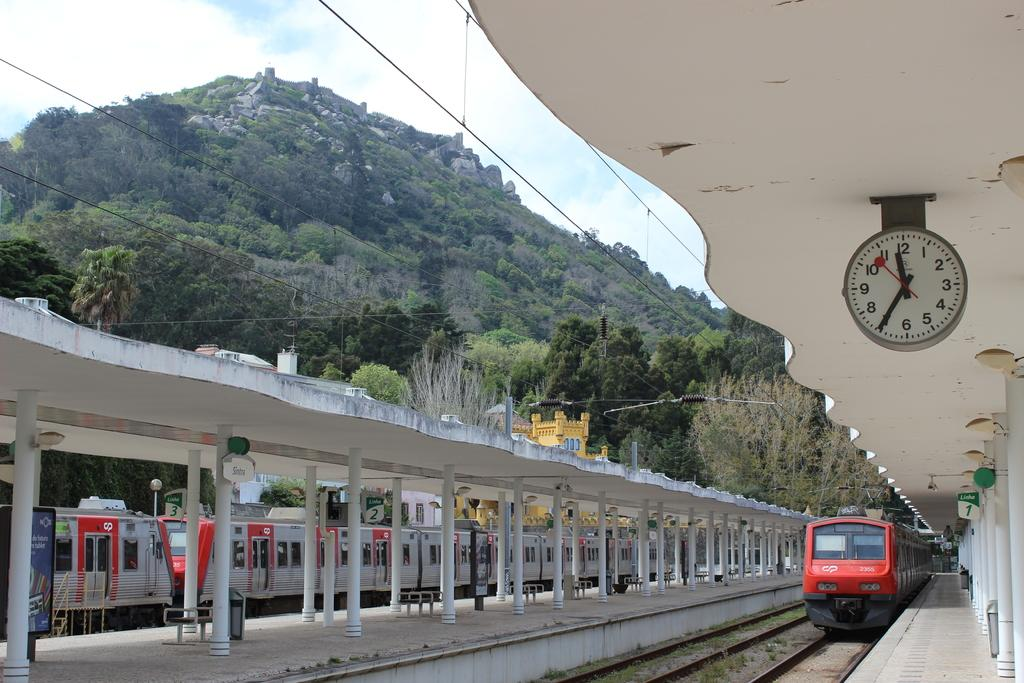<image>
Render a clear and concise summary of the photo. A covered rain platform between two tracks with benches. 